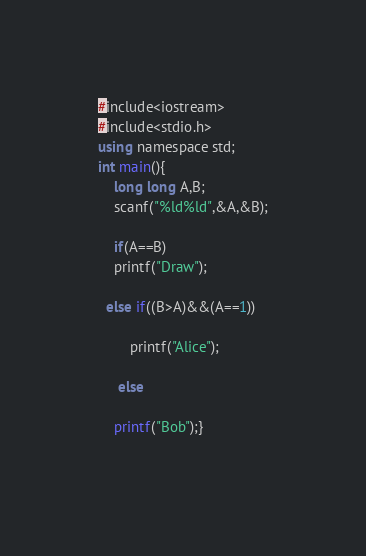<code> <loc_0><loc_0><loc_500><loc_500><_C#_>#include<iostream>
#include<stdio.h>
using namespace std;
int main(){
	long long A,B;
	scanf("%ld%ld",&A,&B);
	
	if(A==B)
	printf("Draw");
	
  else if((B>A)&&(A==1))

		printf("Alice");
		 
	 else 
	
	printf("Bob");}
	</code> 